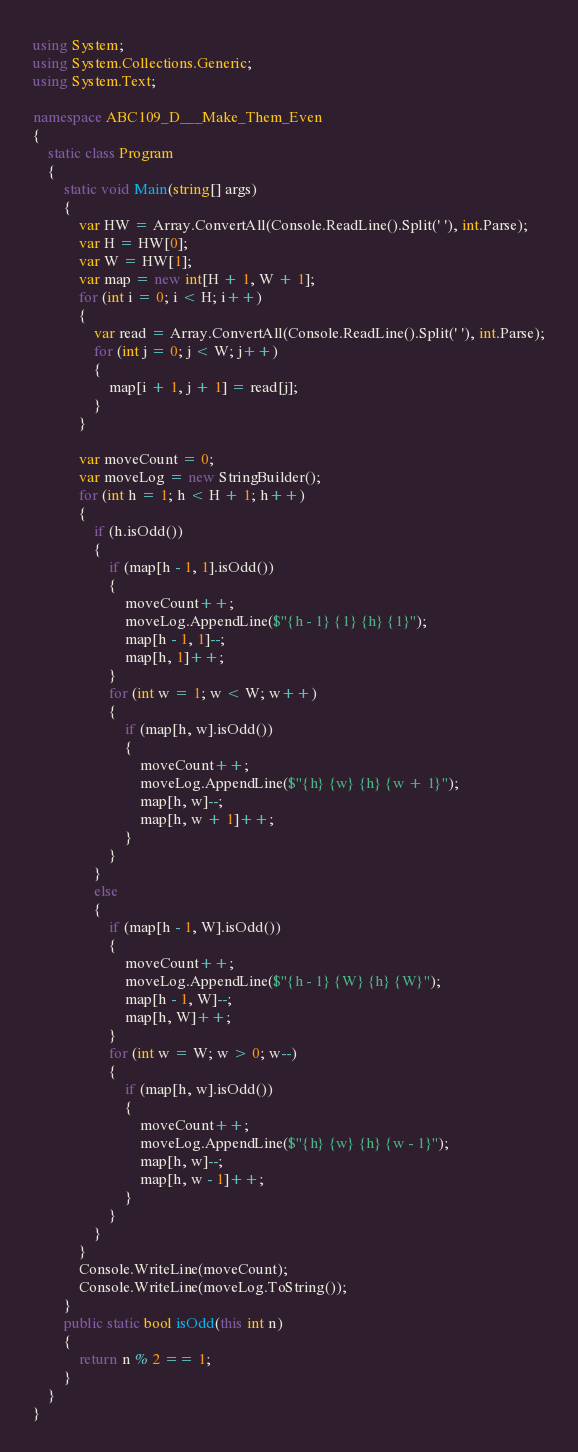Convert code to text. <code><loc_0><loc_0><loc_500><loc_500><_C#_>using System;
using System.Collections.Generic;
using System.Text;

namespace ABC109_D___Make_Them_Even
{
    static class Program
    {
        static void Main(string[] args)
        {
            var HW = Array.ConvertAll(Console.ReadLine().Split(' '), int.Parse);
            var H = HW[0];
            var W = HW[1];
            var map = new int[H + 1, W + 1];
            for (int i = 0; i < H; i++)
            {
                var read = Array.ConvertAll(Console.ReadLine().Split(' '), int.Parse);
                for (int j = 0; j < W; j++)
                {
                    map[i + 1, j + 1] = read[j];
                }
            }

            var moveCount = 0;
            var moveLog = new StringBuilder();
            for (int h = 1; h < H + 1; h++)
            {
                if (h.isOdd())
                {
                    if (map[h - 1, 1].isOdd())
                    {
                        moveCount++;
                        moveLog.AppendLine($"{h - 1} {1} {h} {1}");
                        map[h - 1, 1]--;
                        map[h, 1]++;
                    }
                    for (int w = 1; w < W; w++)
                    {
                        if (map[h, w].isOdd())
                        {
                            moveCount++;
                            moveLog.AppendLine($"{h} {w} {h} {w + 1}");
                            map[h, w]--;
                            map[h, w + 1]++;
                        }
                    }
                }
                else
                {
                    if (map[h - 1, W].isOdd())
                    {
                        moveCount++;
                        moveLog.AppendLine($"{h - 1} {W} {h} {W}");
                        map[h - 1, W]--;
                        map[h, W]++;
                    }
                    for (int w = W; w > 0; w--)
                    {
                        if (map[h, w].isOdd())
                        {
                            moveCount++;
                            moveLog.AppendLine($"{h} {w} {h} {w - 1}");
                            map[h, w]--;
                            map[h, w - 1]++;
                        }
                    }
                }
            }
            Console.WriteLine(moveCount);
            Console.WriteLine(moveLog.ToString());
        }
        public static bool isOdd(this int n)
        {
            return n % 2 == 1;
        }
    }
}
</code> 